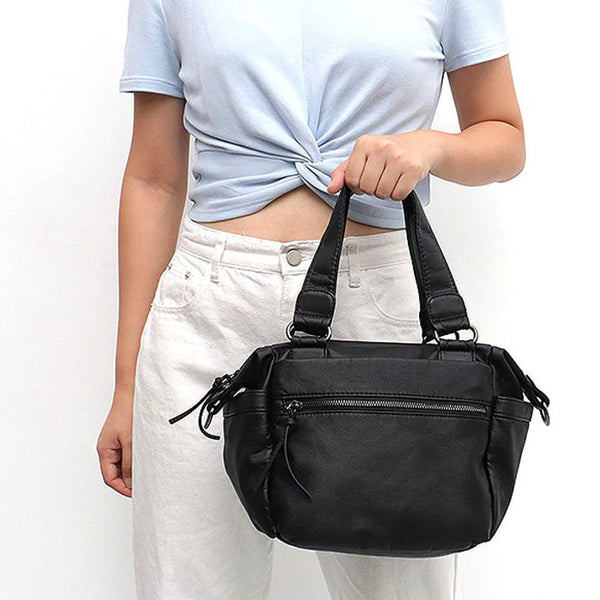What materials do you think the handbag is made from? The handbag appears to be made from a durable synthetic material, likely faux leather or a similar man-made fabric. The texture and finish give it a sleek and polished look, while the material's strength ensures it can withstand daily wear and tear. Would this handbag be suitable for formal events or professional settings? This handbag's design leans more towards a casual and practical aesthetic, making it ideal for everyday activities. However, its sleek black color and modern silhouette give it a polished appearance that can be suitable for semi-formal or professional settings, especially when paired with the right outfit. Can you imagine a scenario where this handbag plays a pivotal role in someone's day? Imagine a busy professional starting her day: She packs her essentials into this handbag, from her laptop and planner to her favorite book for the commute. Throughout the day, the handbag proves to be indispensable—keeping her items organized and easily accessible as she moves from meetings to lunch appointments to after-work errands. Thanks to its practical design, she can carry it comfortably, and its chic appearance seamlessly complements both her business attire and her evening casual wear, ensuring she looks put-together and stylish throughout her diverse daily activities. 